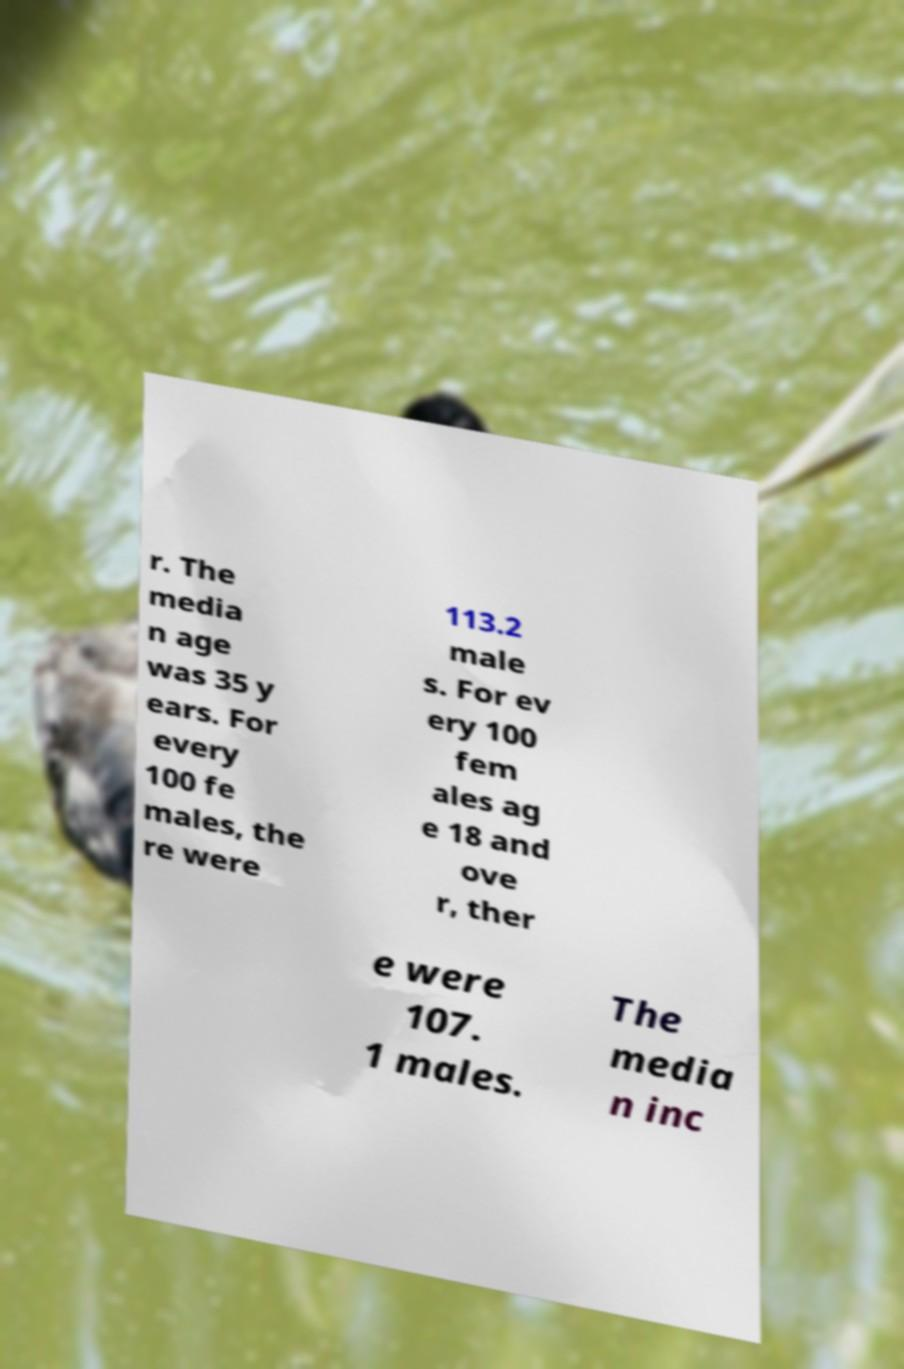Please identify and transcribe the text found in this image. r. The media n age was 35 y ears. For every 100 fe males, the re were 113.2 male s. For ev ery 100 fem ales ag e 18 and ove r, ther e were 107. 1 males. The media n inc 